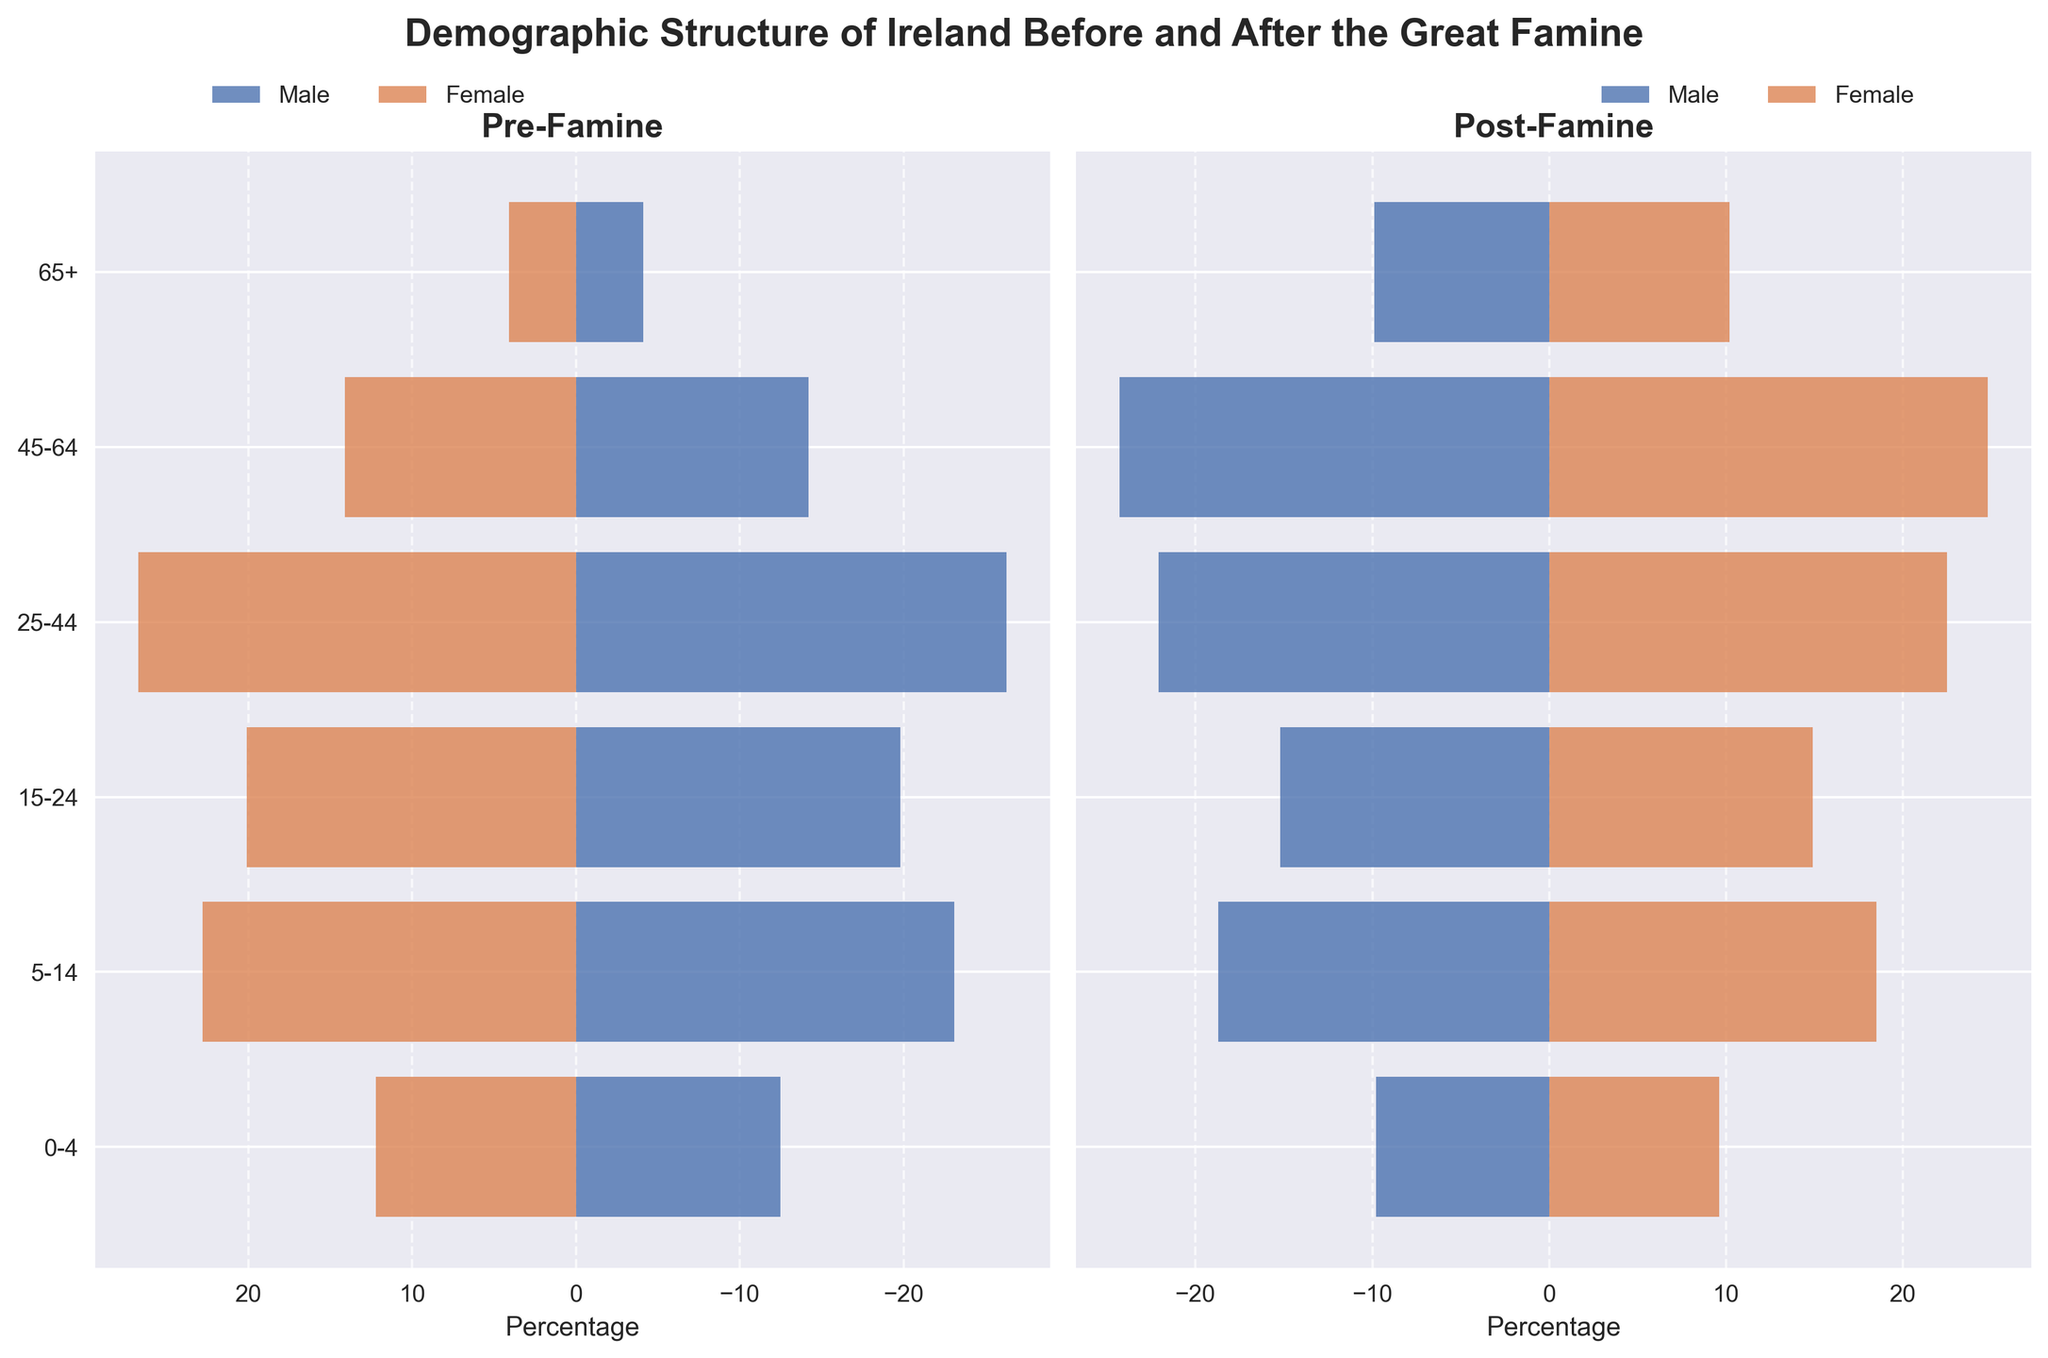What is the title of the figure? The title is typically placed at the top of the figure and summarizes the content or purpose of the visualization. In this case, it should indicate the demographic structure of Ireland before and after the Great Famine.
Answer: Demographic Structure of Ireland Before and After the Great Famine Which age group experienced an increase in both male and female percentages post-famine? By observing the bars representing both males and females in the "Post-Famine" section for all age groups, we can identify the age group where both bars are longer compared to the "Pre-Famine" section.
Answer: 65+ What is the percentage difference for males aged 45-64 between pre-famine and post-famine? Subtract the percentage of males aged 45-64 in the pre-famine era from the percentage in the post-famine era. The difference is calculated as 24.3 - 14.2.
Answer: 10.1 How do the percentages of males and females aged 0-4 compare pre-famine and post-famine? Compare the lengths of the bars (percentages) for the age group 0-4 in both the pre-famine and post-famine sections. For males, it changes from 12.5 to 9.8, and for females, it changes from 12.2 to 9.6.
Answer: Both decreased Which age group had the highest percentage of females pre-famine? Identify the longest bar in the "Female Pre-Famine" section. Observing the bars for each age group, the group with the highest percentage will be identified.
Answer: 25-44 What is the combined percentage of males and females aged 5-14 post-famine? Add the percentages of males and females aged 5-14 in the post-famine section. The combined percentage is calculated as 18.7 + 18.5.
Answer: 37.2 In which age group did females see the largest percentage reduction post-famine compared to pre-famine? For each age group, subtract the "Female Post-Famine" percentage from the "Female Pre-Famine" percentage to find the difference. The age group with the largest (negative) difference is: (22.8-18.5), (20.1-14.9), (26.7-22.5), (14.1-24.8), (4.1-10.2). The largest reduction is: (26.7-22.5) = 4.2
Answer: 25-44 What percentage of the total population was aged 15-24 and female post-famine? This question can be answered by looking at the bar in the "Female Post-Famine" section that corresponds to the age group 15-24.
Answer: 14.9 Which age group had a higher percentage of females than males both pre-famine and post-famine? Identify groups where the female bars are longer than the male bars in both the "Pre-Famine" and "Post-Famine" sections. Compare the bars for each age group.
Answer: 25-44 How does the over-65 age group post-famine compare to pre-famine for both genders? Compare the bars representing the 65+ age group in both pre-famine and post-famine sections for males and females. Both percentages increased from 4.1% to 9.9% for males and from 4.1% to 10.2% for females.
Answer: Both increased significantly 